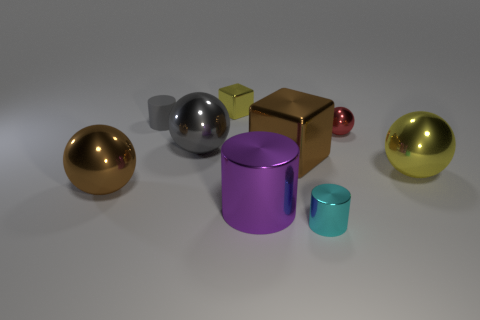There is a yellow metal thing behind the large yellow ball; how big is it?
Make the answer very short. Small. The object that is in front of the large brown metallic block and to the left of the gray metallic sphere has what shape?
Give a very brief answer. Sphere. How many other things are the same shape as the tiny cyan thing?
Ensure brevity in your answer.  2. There is a shiny block that is the same size as the purple metal thing; what is its color?
Your answer should be compact. Brown. What number of objects are either tiny matte objects or purple metal cylinders?
Offer a very short reply. 2. Are there any big gray metallic things behind the gray matte thing?
Your answer should be very brief. No. Is there a large brown cube made of the same material as the large yellow ball?
Make the answer very short. Yes. The sphere that is the same color as the matte thing is what size?
Ensure brevity in your answer.  Large. What number of balls are metallic things or small matte objects?
Provide a short and direct response. 4. Are there more large yellow metallic objects that are to the left of the tiny gray object than tiny cyan things that are in front of the small ball?
Your answer should be very brief. No. 